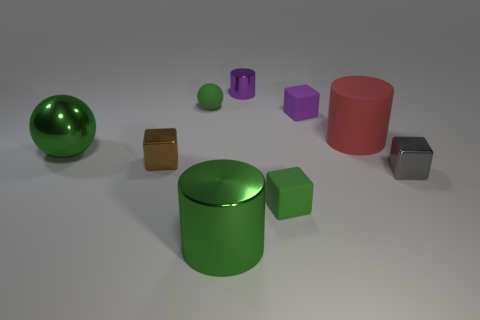Subtract all blue cylinders. Subtract all brown balls. How many cylinders are left? 3 Add 1 green blocks. How many objects exist? 10 Subtract all blocks. How many objects are left? 5 Add 8 big green cylinders. How many big green cylinders are left? 9 Add 7 green metal cylinders. How many green metal cylinders exist? 8 Subtract 0 cyan balls. How many objects are left? 9 Subtract all blue metal cubes. Subtract all red objects. How many objects are left? 8 